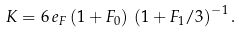Convert formula to latex. <formula><loc_0><loc_0><loc_500><loc_500>K = 6 \, e _ { F } \, ( 1 + F _ { 0 } ) \, \left ( 1 + F _ { 1 } / 3 \right ) ^ { - 1 } .</formula> 